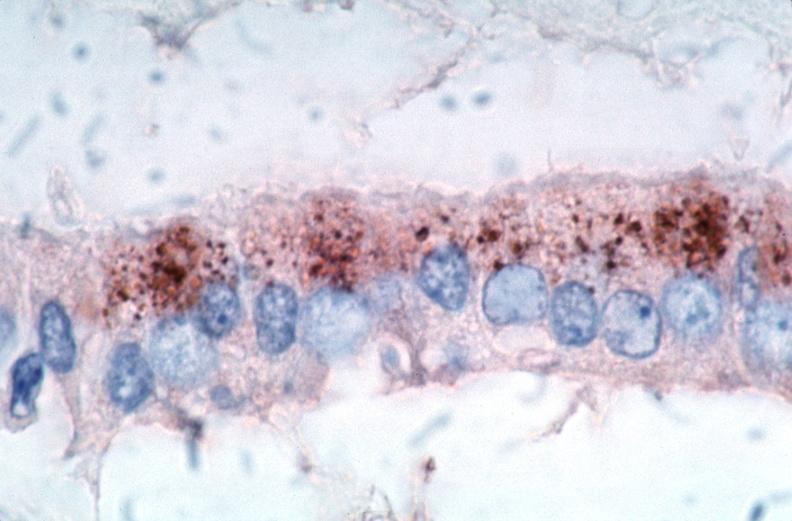where is this from?
Answer the question using a single word or phrase. Vasculature 